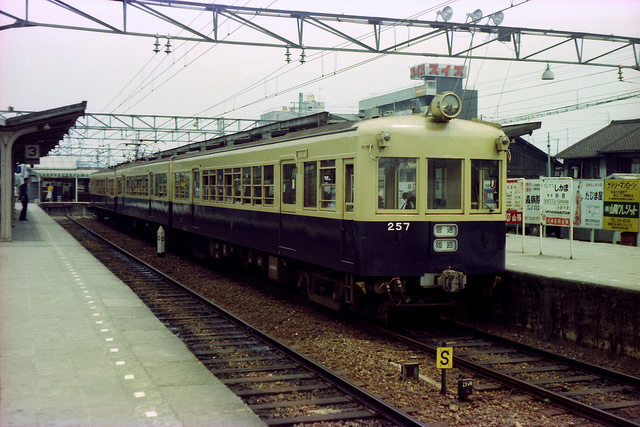Read and extract the text from this image. 257 S 